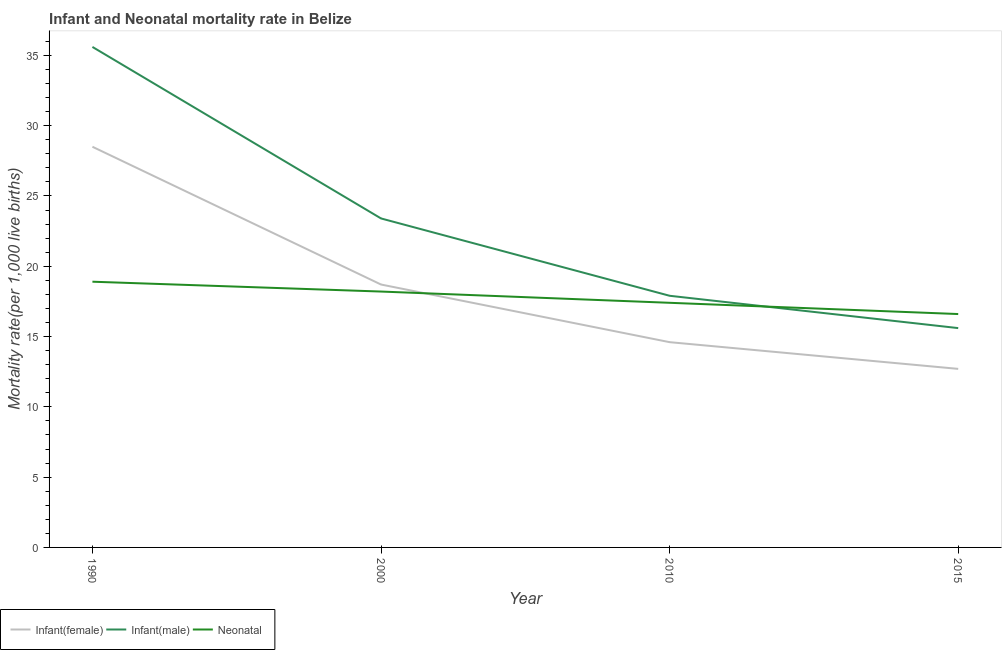How many different coloured lines are there?
Give a very brief answer. 3. What is the neonatal mortality rate in 2010?
Your answer should be compact. 17.4. Across all years, what is the maximum infant mortality rate(male)?
Make the answer very short. 35.6. In which year was the infant mortality rate(male) minimum?
Make the answer very short. 2015. What is the total infant mortality rate(male) in the graph?
Offer a terse response. 92.5. What is the difference between the neonatal mortality rate in 1990 and that in 2010?
Provide a short and direct response. 1.5. What is the difference between the neonatal mortality rate in 2010 and the infant mortality rate(female) in 1990?
Your answer should be compact. -11.1. What is the average neonatal mortality rate per year?
Give a very brief answer. 17.77. In how many years, is the neonatal mortality rate greater than 34?
Make the answer very short. 0. What is the ratio of the neonatal mortality rate in 2010 to that in 2015?
Ensure brevity in your answer.  1.05. What is the difference between the highest and the second highest infant mortality rate(male)?
Your answer should be very brief. 12.2. What is the difference between the highest and the lowest neonatal mortality rate?
Your response must be concise. 2.3. Is the sum of the infant mortality rate(female) in 1990 and 2000 greater than the maximum neonatal mortality rate across all years?
Offer a very short reply. Yes. Does the infant mortality rate(female) monotonically increase over the years?
Offer a very short reply. No. Is the neonatal mortality rate strictly less than the infant mortality rate(male) over the years?
Keep it short and to the point. No. How many lines are there?
Your answer should be compact. 3. How many years are there in the graph?
Your response must be concise. 4. What is the difference between two consecutive major ticks on the Y-axis?
Provide a succinct answer. 5. Are the values on the major ticks of Y-axis written in scientific E-notation?
Provide a succinct answer. No. Does the graph contain grids?
Keep it short and to the point. No. Where does the legend appear in the graph?
Your answer should be very brief. Bottom left. How many legend labels are there?
Your answer should be compact. 3. What is the title of the graph?
Offer a terse response. Infant and Neonatal mortality rate in Belize. Does "Social insurance" appear as one of the legend labels in the graph?
Keep it short and to the point. No. What is the label or title of the X-axis?
Provide a succinct answer. Year. What is the label or title of the Y-axis?
Your answer should be compact. Mortality rate(per 1,0 live births). What is the Mortality rate(per 1,000 live births) in Infant(female) in 1990?
Ensure brevity in your answer.  28.5. What is the Mortality rate(per 1,000 live births) in Infant(male) in 1990?
Your response must be concise. 35.6. What is the Mortality rate(per 1,000 live births) in Infant(male) in 2000?
Keep it short and to the point. 23.4. What is the Mortality rate(per 1,000 live births) of Neonatal  in 2000?
Your answer should be very brief. 18.2. What is the Mortality rate(per 1,000 live births) of Infant(male) in 2010?
Ensure brevity in your answer.  17.9. What is the Mortality rate(per 1,000 live births) in Neonatal  in 2010?
Provide a succinct answer. 17.4. Across all years, what is the maximum Mortality rate(per 1,000 live births) of Infant(male)?
Offer a terse response. 35.6. Across all years, what is the maximum Mortality rate(per 1,000 live births) of Neonatal ?
Offer a terse response. 18.9. Across all years, what is the minimum Mortality rate(per 1,000 live births) of Infant(male)?
Keep it short and to the point. 15.6. Across all years, what is the minimum Mortality rate(per 1,000 live births) in Neonatal ?
Provide a succinct answer. 16.6. What is the total Mortality rate(per 1,000 live births) of Infant(female) in the graph?
Give a very brief answer. 74.5. What is the total Mortality rate(per 1,000 live births) in Infant(male) in the graph?
Your answer should be very brief. 92.5. What is the total Mortality rate(per 1,000 live births) of Neonatal  in the graph?
Provide a succinct answer. 71.1. What is the difference between the Mortality rate(per 1,000 live births) of Infant(female) in 1990 and that in 2000?
Give a very brief answer. 9.8. What is the difference between the Mortality rate(per 1,000 live births) of Infant(female) in 2000 and that in 2010?
Your response must be concise. 4.1. What is the difference between the Mortality rate(per 1,000 live births) of Infant(female) in 2000 and that in 2015?
Make the answer very short. 6. What is the difference between the Mortality rate(per 1,000 live births) of Neonatal  in 2010 and that in 2015?
Your response must be concise. 0.8. What is the difference between the Mortality rate(per 1,000 live births) in Infant(female) in 1990 and the Mortality rate(per 1,000 live births) in Neonatal  in 2000?
Offer a very short reply. 10.3. What is the difference between the Mortality rate(per 1,000 live births) of Infant(male) in 1990 and the Mortality rate(per 1,000 live births) of Neonatal  in 2015?
Your answer should be compact. 19. What is the difference between the Mortality rate(per 1,000 live births) in Infant(female) in 2000 and the Mortality rate(per 1,000 live births) in Infant(male) in 2010?
Keep it short and to the point. 0.8. What is the difference between the Mortality rate(per 1,000 live births) in Infant(female) in 2000 and the Mortality rate(per 1,000 live births) in Neonatal  in 2010?
Offer a terse response. 1.3. What is the difference between the Mortality rate(per 1,000 live births) of Infant(female) in 2000 and the Mortality rate(per 1,000 live births) of Infant(male) in 2015?
Offer a very short reply. 3.1. What is the difference between the Mortality rate(per 1,000 live births) in Infant(female) in 2010 and the Mortality rate(per 1,000 live births) in Neonatal  in 2015?
Provide a succinct answer. -2. What is the difference between the Mortality rate(per 1,000 live births) in Infant(male) in 2010 and the Mortality rate(per 1,000 live births) in Neonatal  in 2015?
Give a very brief answer. 1.3. What is the average Mortality rate(per 1,000 live births) in Infant(female) per year?
Keep it short and to the point. 18.62. What is the average Mortality rate(per 1,000 live births) of Infant(male) per year?
Offer a very short reply. 23.12. What is the average Mortality rate(per 1,000 live births) of Neonatal  per year?
Provide a short and direct response. 17.77. In the year 1990, what is the difference between the Mortality rate(per 1,000 live births) of Infant(female) and Mortality rate(per 1,000 live births) of Infant(male)?
Offer a terse response. -7.1. In the year 1990, what is the difference between the Mortality rate(per 1,000 live births) in Infant(female) and Mortality rate(per 1,000 live births) in Neonatal ?
Your answer should be very brief. 9.6. In the year 2000, what is the difference between the Mortality rate(per 1,000 live births) of Infant(female) and Mortality rate(per 1,000 live births) of Infant(male)?
Make the answer very short. -4.7. In the year 2000, what is the difference between the Mortality rate(per 1,000 live births) in Infant(female) and Mortality rate(per 1,000 live births) in Neonatal ?
Your response must be concise. 0.5. In the year 2000, what is the difference between the Mortality rate(per 1,000 live births) of Infant(male) and Mortality rate(per 1,000 live births) of Neonatal ?
Ensure brevity in your answer.  5.2. In the year 2010, what is the difference between the Mortality rate(per 1,000 live births) in Infant(female) and Mortality rate(per 1,000 live births) in Neonatal ?
Your answer should be very brief. -2.8. In the year 2010, what is the difference between the Mortality rate(per 1,000 live births) of Infant(male) and Mortality rate(per 1,000 live births) of Neonatal ?
Ensure brevity in your answer.  0.5. In the year 2015, what is the difference between the Mortality rate(per 1,000 live births) in Infant(female) and Mortality rate(per 1,000 live births) in Neonatal ?
Keep it short and to the point. -3.9. What is the ratio of the Mortality rate(per 1,000 live births) of Infant(female) in 1990 to that in 2000?
Make the answer very short. 1.52. What is the ratio of the Mortality rate(per 1,000 live births) in Infant(male) in 1990 to that in 2000?
Your answer should be compact. 1.52. What is the ratio of the Mortality rate(per 1,000 live births) in Neonatal  in 1990 to that in 2000?
Your response must be concise. 1.04. What is the ratio of the Mortality rate(per 1,000 live births) of Infant(female) in 1990 to that in 2010?
Your response must be concise. 1.95. What is the ratio of the Mortality rate(per 1,000 live births) of Infant(male) in 1990 to that in 2010?
Your response must be concise. 1.99. What is the ratio of the Mortality rate(per 1,000 live births) of Neonatal  in 1990 to that in 2010?
Your response must be concise. 1.09. What is the ratio of the Mortality rate(per 1,000 live births) of Infant(female) in 1990 to that in 2015?
Your answer should be compact. 2.24. What is the ratio of the Mortality rate(per 1,000 live births) of Infant(male) in 1990 to that in 2015?
Your answer should be compact. 2.28. What is the ratio of the Mortality rate(per 1,000 live births) of Neonatal  in 1990 to that in 2015?
Offer a terse response. 1.14. What is the ratio of the Mortality rate(per 1,000 live births) in Infant(female) in 2000 to that in 2010?
Your answer should be compact. 1.28. What is the ratio of the Mortality rate(per 1,000 live births) of Infant(male) in 2000 to that in 2010?
Make the answer very short. 1.31. What is the ratio of the Mortality rate(per 1,000 live births) in Neonatal  in 2000 to that in 2010?
Your answer should be compact. 1.05. What is the ratio of the Mortality rate(per 1,000 live births) in Infant(female) in 2000 to that in 2015?
Provide a short and direct response. 1.47. What is the ratio of the Mortality rate(per 1,000 live births) in Infant(male) in 2000 to that in 2015?
Keep it short and to the point. 1.5. What is the ratio of the Mortality rate(per 1,000 live births) in Neonatal  in 2000 to that in 2015?
Your answer should be compact. 1.1. What is the ratio of the Mortality rate(per 1,000 live births) of Infant(female) in 2010 to that in 2015?
Your response must be concise. 1.15. What is the ratio of the Mortality rate(per 1,000 live births) of Infant(male) in 2010 to that in 2015?
Your response must be concise. 1.15. What is the ratio of the Mortality rate(per 1,000 live births) in Neonatal  in 2010 to that in 2015?
Your answer should be compact. 1.05. What is the difference between the highest and the second highest Mortality rate(per 1,000 live births) of Infant(female)?
Make the answer very short. 9.8. What is the difference between the highest and the second highest Mortality rate(per 1,000 live births) of Infant(male)?
Your answer should be very brief. 12.2. What is the difference between the highest and the second highest Mortality rate(per 1,000 live births) of Neonatal ?
Your response must be concise. 0.7. What is the difference between the highest and the lowest Mortality rate(per 1,000 live births) of Infant(female)?
Make the answer very short. 15.8. What is the difference between the highest and the lowest Mortality rate(per 1,000 live births) of Neonatal ?
Your answer should be compact. 2.3. 